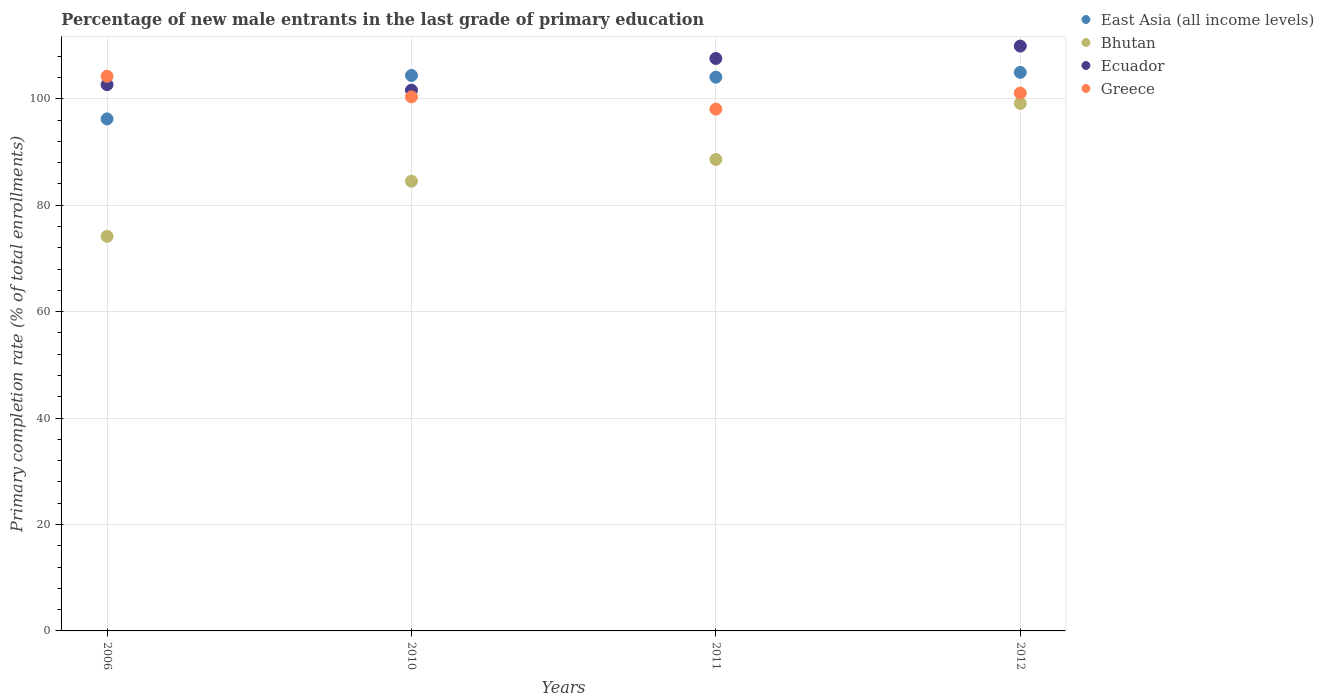How many different coloured dotlines are there?
Your response must be concise. 4. Is the number of dotlines equal to the number of legend labels?
Your answer should be compact. Yes. What is the percentage of new male entrants in Bhutan in 2011?
Your answer should be compact. 88.61. Across all years, what is the maximum percentage of new male entrants in Greece?
Your answer should be compact. 104.24. Across all years, what is the minimum percentage of new male entrants in Bhutan?
Your answer should be compact. 74.16. In which year was the percentage of new male entrants in Ecuador minimum?
Your answer should be compact. 2010. What is the total percentage of new male entrants in Bhutan in the graph?
Ensure brevity in your answer.  346.42. What is the difference between the percentage of new male entrants in Bhutan in 2010 and that in 2011?
Your response must be concise. -4.09. What is the difference between the percentage of new male entrants in Greece in 2011 and the percentage of new male entrants in East Asia (all income levels) in 2012?
Keep it short and to the point. -6.91. What is the average percentage of new male entrants in East Asia (all income levels) per year?
Ensure brevity in your answer.  102.41. In the year 2012, what is the difference between the percentage of new male entrants in Bhutan and percentage of new male entrants in East Asia (all income levels)?
Provide a short and direct response. -5.83. What is the ratio of the percentage of new male entrants in Greece in 2006 to that in 2012?
Ensure brevity in your answer.  1.03. Is the percentage of new male entrants in Greece in 2006 less than that in 2012?
Offer a very short reply. No. Is the difference between the percentage of new male entrants in Bhutan in 2006 and 2011 greater than the difference between the percentage of new male entrants in East Asia (all income levels) in 2006 and 2011?
Offer a terse response. No. What is the difference between the highest and the second highest percentage of new male entrants in East Asia (all income levels)?
Your answer should be very brief. 0.58. What is the difference between the highest and the lowest percentage of new male entrants in Bhutan?
Make the answer very short. 24.98. Is the sum of the percentage of new male entrants in East Asia (all income levels) in 2010 and 2011 greater than the maximum percentage of new male entrants in Bhutan across all years?
Provide a succinct answer. Yes. Is it the case that in every year, the sum of the percentage of new male entrants in Greece and percentage of new male entrants in East Asia (all income levels)  is greater than the sum of percentage of new male entrants in Bhutan and percentage of new male entrants in Ecuador?
Your answer should be very brief. Yes. Is it the case that in every year, the sum of the percentage of new male entrants in Ecuador and percentage of new male entrants in Greece  is greater than the percentage of new male entrants in Bhutan?
Your response must be concise. Yes. Does the percentage of new male entrants in Bhutan monotonically increase over the years?
Provide a short and direct response. Yes. How many years are there in the graph?
Your answer should be compact. 4. Are the values on the major ticks of Y-axis written in scientific E-notation?
Your answer should be very brief. No. What is the title of the graph?
Provide a short and direct response. Percentage of new male entrants in the last grade of primary education. Does "Niger" appear as one of the legend labels in the graph?
Your answer should be compact. No. What is the label or title of the Y-axis?
Give a very brief answer. Primary completion rate (% of total enrollments). What is the Primary completion rate (% of total enrollments) of East Asia (all income levels) in 2006?
Ensure brevity in your answer.  96.22. What is the Primary completion rate (% of total enrollments) in Bhutan in 2006?
Your answer should be very brief. 74.16. What is the Primary completion rate (% of total enrollments) in Ecuador in 2006?
Provide a succinct answer. 102.67. What is the Primary completion rate (% of total enrollments) in Greece in 2006?
Provide a short and direct response. 104.24. What is the Primary completion rate (% of total enrollments) of East Asia (all income levels) in 2010?
Give a very brief answer. 104.39. What is the Primary completion rate (% of total enrollments) of Bhutan in 2010?
Your answer should be compact. 84.52. What is the Primary completion rate (% of total enrollments) in Ecuador in 2010?
Give a very brief answer. 101.63. What is the Primary completion rate (% of total enrollments) of Greece in 2010?
Ensure brevity in your answer.  100.36. What is the Primary completion rate (% of total enrollments) in East Asia (all income levels) in 2011?
Make the answer very short. 104.07. What is the Primary completion rate (% of total enrollments) in Bhutan in 2011?
Offer a terse response. 88.61. What is the Primary completion rate (% of total enrollments) of Ecuador in 2011?
Provide a short and direct response. 107.58. What is the Primary completion rate (% of total enrollments) of Greece in 2011?
Offer a terse response. 98.06. What is the Primary completion rate (% of total enrollments) of East Asia (all income levels) in 2012?
Make the answer very short. 104.97. What is the Primary completion rate (% of total enrollments) of Bhutan in 2012?
Give a very brief answer. 99.14. What is the Primary completion rate (% of total enrollments) in Ecuador in 2012?
Your answer should be compact. 109.91. What is the Primary completion rate (% of total enrollments) of Greece in 2012?
Provide a succinct answer. 101.08. Across all years, what is the maximum Primary completion rate (% of total enrollments) in East Asia (all income levels)?
Your answer should be compact. 104.97. Across all years, what is the maximum Primary completion rate (% of total enrollments) of Bhutan?
Give a very brief answer. 99.14. Across all years, what is the maximum Primary completion rate (% of total enrollments) in Ecuador?
Offer a terse response. 109.91. Across all years, what is the maximum Primary completion rate (% of total enrollments) of Greece?
Your answer should be compact. 104.24. Across all years, what is the minimum Primary completion rate (% of total enrollments) in East Asia (all income levels)?
Your answer should be very brief. 96.22. Across all years, what is the minimum Primary completion rate (% of total enrollments) of Bhutan?
Offer a terse response. 74.16. Across all years, what is the minimum Primary completion rate (% of total enrollments) of Ecuador?
Keep it short and to the point. 101.63. Across all years, what is the minimum Primary completion rate (% of total enrollments) in Greece?
Your response must be concise. 98.06. What is the total Primary completion rate (% of total enrollments) of East Asia (all income levels) in the graph?
Your answer should be compact. 409.65. What is the total Primary completion rate (% of total enrollments) of Bhutan in the graph?
Keep it short and to the point. 346.42. What is the total Primary completion rate (% of total enrollments) of Ecuador in the graph?
Your answer should be compact. 421.79. What is the total Primary completion rate (% of total enrollments) in Greece in the graph?
Make the answer very short. 403.74. What is the difference between the Primary completion rate (% of total enrollments) in East Asia (all income levels) in 2006 and that in 2010?
Give a very brief answer. -8.17. What is the difference between the Primary completion rate (% of total enrollments) in Bhutan in 2006 and that in 2010?
Your answer should be compact. -10.36. What is the difference between the Primary completion rate (% of total enrollments) of Ecuador in 2006 and that in 2010?
Your answer should be compact. 1.04. What is the difference between the Primary completion rate (% of total enrollments) of Greece in 2006 and that in 2010?
Offer a terse response. 3.87. What is the difference between the Primary completion rate (% of total enrollments) of East Asia (all income levels) in 2006 and that in 2011?
Provide a short and direct response. -7.85. What is the difference between the Primary completion rate (% of total enrollments) in Bhutan in 2006 and that in 2011?
Provide a succinct answer. -14.45. What is the difference between the Primary completion rate (% of total enrollments) of Ecuador in 2006 and that in 2011?
Offer a terse response. -4.92. What is the difference between the Primary completion rate (% of total enrollments) in Greece in 2006 and that in 2011?
Provide a succinct answer. 6.18. What is the difference between the Primary completion rate (% of total enrollments) of East Asia (all income levels) in 2006 and that in 2012?
Provide a short and direct response. -8.75. What is the difference between the Primary completion rate (% of total enrollments) of Bhutan in 2006 and that in 2012?
Your response must be concise. -24.98. What is the difference between the Primary completion rate (% of total enrollments) of Ecuador in 2006 and that in 2012?
Offer a very short reply. -7.24. What is the difference between the Primary completion rate (% of total enrollments) in Greece in 2006 and that in 2012?
Make the answer very short. 3.16. What is the difference between the Primary completion rate (% of total enrollments) in East Asia (all income levels) in 2010 and that in 2011?
Your answer should be very brief. 0.32. What is the difference between the Primary completion rate (% of total enrollments) of Bhutan in 2010 and that in 2011?
Offer a terse response. -4.09. What is the difference between the Primary completion rate (% of total enrollments) of Ecuador in 2010 and that in 2011?
Ensure brevity in your answer.  -5.96. What is the difference between the Primary completion rate (% of total enrollments) in Greece in 2010 and that in 2011?
Offer a very short reply. 2.3. What is the difference between the Primary completion rate (% of total enrollments) of East Asia (all income levels) in 2010 and that in 2012?
Keep it short and to the point. -0.58. What is the difference between the Primary completion rate (% of total enrollments) in Bhutan in 2010 and that in 2012?
Keep it short and to the point. -14.62. What is the difference between the Primary completion rate (% of total enrollments) of Ecuador in 2010 and that in 2012?
Provide a succinct answer. -8.28. What is the difference between the Primary completion rate (% of total enrollments) of Greece in 2010 and that in 2012?
Your response must be concise. -0.72. What is the difference between the Primary completion rate (% of total enrollments) in East Asia (all income levels) in 2011 and that in 2012?
Offer a terse response. -0.9. What is the difference between the Primary completion rate (% of total enrollments) in Bhutan in 2011 and that in 2012?
Provide a succinct answer. -10.53. What is the difference between the Primary completion rate (% of total enrollments) of Ecuador in 2011 and that in 2012?
Make the answer very short. -2.33. What is the difference between the Primary completion rate (% of total enrollments) of Greece in 2011 and that in 2012?
Your answer should be compact. -3.02. What is the difference between the Primary completion rate (% of total enrollments) of East Asia (all income levels) in 2006 and the Primary completion rate (% of total enrollments) of Bhutan in 2010?
Provide a short and direct response. 11.7. What is the difference between the Primary completion rate (% of total enrollments) in East Asia (all income levels) in 2006 and the Primary completion rate (% of total enrollments) in Ecuador in 2010?
Your answer should be very brief. -5.4. What is the difference between the Primary completion rate (% of total enrollments) of East Asia (all income levels) in 2006 and the Primary completion rate (% of total enrollments) of Greece in 2010?
Ensure brevity in your answer.  -4.14. What is the difference between the Primary completion rate (% of total enrollments) in Bhutan in 2006 and the Primary completion rate (% of total enrollments) in Ecuador in 2010?
Your answer should be compact. -27.47. What is the difference between the Primary completion rate (% of total enrollments) of Bhutan in 2006 and the Primary completion rate (% of total enrollments) of Greece in 2010?
Your answer should be compact. -26.2. What is the difference between the Primary completion rate (% of total enrollments) in Ecuador in 2006 and the Primary completion rate (% of total enrollments) in Greece in 2010?
Keep it short and to the point. 2.31. What is the difference between the Primary completion rate (% of total enrollments) of East Asia (all income levels) in 2006 and the Primary completion rate (% of total enrollments) of Bhutan in 2011?
Your answer should be compact. 7.62. What is the difference between the Primary completion rate (% of total enrollments) in East Asia (all income levels) in 2006 and the Primary completion rate (% of total enrollments) in Ecuador in 2011?
Offer a very short reply. -11.36. What is the difference between the Primary completion rate (% of total enrollments) in East Asia (all income levels) in 2006 and the Primary completion rate (% of total enrollments) in Greece in 2011?
Offer a terse response. -1.84. What is the difference between the Primary completion rate (% of total enrollments) of Bhutan in 2006 and the Primary completion rate (% of total enrollments) of Ecuador in 2011?
Keep it short and to the point. -33.43. What is the difference between the Primary completion rate (% of total enrollments) of Bhutan in 2006 and the Primary completion rate (% of total enrollments) of Greece in 2011?
Provide a short and direct response. -23.9. What is the difference between the Primary completion rate (% of total enrollments) in Ecuador in 2006 and the Primary completion rate (% of total enrollments) in Greece in 2011?
Offer a terse response. 4.61. What is the difference between the Primary completion rate (% of total enrollments) of East Asia (all income levels) in 2006 and the Primary completion rate (% of total enrollments) of Bhutan in 2012?
Offer a terse response. -2.91. What is the difference between the Primary completion rate (% of total enrollments) in East Asia (all income levels) in 2006 and the Primary completion rate (% of total enrollments) in Ecuador in 2012?
Your answer should be very brief. -13.69. What is the difference between the Primary completion rate (% of total enrollments) of East Asia (all income levels) in 2006 and the Primary completion rate (% of total enrollments) of Greece in 2012?
Keep it short and to the point. -4.86. What is the difference between the Primary completion rate (% of total enrollments) in Bhutan in 2006 and the Primary completion rate (% of total enrollments) in Ecuador in 2012?
Offer a terse response. -35.75. What is the difference between the Primary completion rate (% of total enrollments) in Bhutan in 2006 and the Primary completion rate (% of total enrollments) in Greece in 2012?
Keep it short and to the point. -26.92. What is the difference between the Primary completion rate (% of total enrollments) in Ecuador in 2006 and the Primary completion rate (% of total enrollments) in Greece in 2012?
Offer a very short reply. 1.59. What is the difference between the Primary completion rate (% of total enrollments) of East Asia (all income levels) in 2010 and the Primary completion rate (% of total enrollments) of Bhutan in 2011?
Give a very brief answer. 15.79. What is the difference between the Primary completion rate (% of total enrollments) in East Asia (all income levels) in 2010 and the Primary completion rate (% of total enrollments) in Ecuador in 2011?
Your answer should be compact. -3.19. What is the difference between the Primary completion rate (% of total enrollments) of East Asia (all income levels) in 2010 and the Primary completion rate (% of total enrollments) of Greece in 2011?
Your response must be concise. 6.33. What is the difference between the Primary completion rate (% of total enrollments) in Bhutan in 2010 and the Primary completion rate (% of total enrollments) in Ecuador in 2011?
Provide a short and direct response. -23.06. What is the difference between the Primary completion rate (% of total enrollments) in Bhutan in 2010 and the Primary completion rate (% of total enrollments) in Greece in 2011?
Your response must be concise. -13.54. What is the difference between the Primary completion rate (% of total enrollments) in Ecuador in 2010 and the Primary completion rate (% of total enrollments) in Greece in 2011?
Ensure brevity in your answer.  3.57. What is the difference between the Primary completion rate (% of total enrollments) of East Asia (all income levels) in 2010 and the Primary completion rate (% of total enrollments) of Bhutan in 2012?
Offer a terse response. 5.26. What is the difference between the Primary completion rate (% of total enrollments) of East Asia (all income levels) in 2010 and the Primary completion rate (% of total enrollments) of Ecuador in 2012?
Provide a short and direct response. -5.52. What is the difference between the Primary completion rate (% of total enrollments) in East Asia (all income levels) in 2010 and the Primary completion rate (% of total enrollments) in Greece in 2012?
Give a very brief answer. 3.31. What is the difference between the Primary completion rate (% of total enrollments) of Bhutan in 2010 and the Primary completion rate (% of total enrollments) of Ecuador in 2012?
Ensure brevity in your answer.  -25.39. What is the difference between the Primary completion rate (% of total enrollments) of Bhutan in 2010 and the Primary completion rate (% of total enrollments) of Greece in 2012?
Your answer should be very brief. -16.56. What is the difference between the Primary completion rate (% of total enrollments) of Ecuador in 2010 and the Primary completion rate (% of total enrollments) of Greece in 2012?
Offer a very short reply. 0.55. What is the difference between the Primary completion rate (% of total enrollments) in East Asia (all income levels) in 2011 and the Primary completion rate (% of total enrollments) in Bhutan in 2012?
Provide a succinct answer. 4.93. What is the difference between the Primary completion rate (% of total enrollments) in East Asia (all income levels) in 2011 and the Primary completion rate (% of total enrollments) in Ecuador in 2012?
Your answer should be compact. -5.84. What is the difference between the Primary completion rate (% of total enrollments) in East Asia (all income levels) in 2011 and the Primary completion rate (% of total enrollments) in Greece in 2012?
Offer a terse response. 2.99. What is the difference between the Primary completion rate (% of total enrollments) in Bhutan in 2011 and the Primary completion rate (% of total enrollments) in Ecuador in 2012?
Your answer should be very brief. -21.3. What is the difference between the Primary completion rate (% of total enrollments) in Bhutan in 2011 and the Primary completion rate (% of total enrollments) in Greece in 2012?
Provide a short and direct response. -12.47. What is the difference between the Primary completion rate (% of total enrollments) of Ecuador in 2011 and the Primary completion rate (% of total enrollments) of Greece in 2012?
Your answer should be very brief. 6.5. What is the average Primary completion rate (% of total enrollments) of East Asia (all income levels) per year?
Ensure brevity in your answer.  102.41. What is the average Primary completion rate (% of total enrollments) of Bhutan per year?
Keep it short and to the point. 86.6. What is the average Primary completion rate (% of total enrollments) of Ecuador per year?
Your answer should be very brief. 105.45. What is the average Primary completion rate (% of total enrollments) in Greece per year?
Offer a very short reply. 100.93. In the year 2006, what is the difference between the Primary completion rate (% of total enrollments) in East Asia (all income levels) and Primary completion rate (% of total enrollments) in Bhutan?
Make the answer very short. 22.07. In the year 2006, what is the difference between the Primary completion rate (% of total enrollments) of East Asia (all income levels) and Primary completion rate (% of total enrollments) of Ecuador?
Offer a terse response. -6.45. In the year 2006, what is the difference between the Primary completion rate (% of total enrollments) in East Asia (all income levels) and Primary completion rate (% of total enrollments) in Greece?
Provide a short and direct response. -8.01. In the year 2006, what is the difference between the Primary completion rate (% of total enrollments) of Bhutan and Primary completion rate (% of total enrollments) of Ecuador?
Keep it short and to the point. -28.51. In the year 2006, what is the difference between the Primary completion rate (% of total enrollments) in Bhutan and Primary completion rate (% of total enrollments) in Greece?
Offer a terse response. -30.08. In the year 2006, what is the difference between the Primary completion rate (% of total enrollments) in Ecuador and Primary completion rate (% of total enrollments) in Greece?
Ensure brevity in your answer.  -1.57. In the year 2010, what is the difference between the Primary completion rate (% of total enrollments) in East Asia (all income levels) and Primary completion rate (% of total enrollments) in Bhutan?
Offer a very short reply. 19.87. In the year 2010, what is the difference between the Primary completion rate (% of total enrollments) in East Asia (all income levels) and Primary completion rate (% of total enrollments) in Ecuador?
Give a very brief answer. 2.76. In the year 2010, what is the difference between the Primary completion rate (% of total enrollments) of East Asia (all income levels) and Primary completion rate (% of total enrollments) of Greece?
Keep it short and to the point. 4.03. In the year 2010, what is the difference between the Primary completion rate (% of total enrollments) of Bhutan and Primary completion rate (% of total enrollments) of Ecuador?
Provide a short and direct response. -17.11. In the year 2010, what is the difference between the Primary completion rate (% of total enrollments) of Bhutan and Primary completion rate (% of total enrollments) of Greece?
Provide a short and direct response. -15.84. In the year 2010, what is the difference between the Primary completion rate (% of total enrollments) in Ecuador and Primary completion rate (% of total enrollments) in Greece?
Ensure brevity in your answer.  1.26. In the year 2011, what is the difference between the Primary completion rate (% of total enrollments) in East Asia (all income levels) and Primary completion rate (% of total enrollments) in Bhutan?
Your answer should be very brief. 15.46. In the year 2011, what is the difference between the Primary completion rate (% of total enrollments) of East Asia (all income levels) and Primary completion rate (% of total enrollments) of Ecuador?
Your answer should be very brief. -3.51. In the year 2011, what is the difference between the Primary completion rate (% of total enrollments) in East Asia (all income levels) and Primary completion rate (% of total enrollments) in Greece?
Provide a succinct answer. 6.01. In the year 2011, what is the difference between the Primary completion rate (% of total enrollments) of Bhutan and Primary completion rate (% of total enrollments) of Ecuador?
Make the answer very short. -18.98. In the year 2011, what is the difference between the Primary completion rate (% of total enrollments) of Bhutan and Primary completion rate (% of total enrollments) of Greece?
Keep it short and to the point. -9.45. In the year 2011, what is the difference between the Primary completion rate (% of total enrollments) of Ecuador and Primary completion rate (% of total enrollments) of Greece?
Keep it short and to the point. 9.52. In the year 2012, what is the difference between the Primary completion rate (% of total enrollments) of East Asia (all income levels) and Primary completion rate (% of total enrollments) of Bhutan?
Ensure brevity in your answer.  5.83. In the year 2012, what is the difference between the Primary completion rate (% of total enrollments) of East Asia (all income levels) and Primary completion rate (% of total enrollments) of Ecuador?
Provide a short and direct response. -4.94. In the year 2012, what is the difference between the Primary completion rate (% of total enrollments) in East Asia (all income levels) and Primary completion rate (% of total enrollments) in Greece?
Offer a terse response. 3.89. In the year 2012, what is the difference between the Primary completion rate (% of total enrollments) in Bhutan and Primary completion rate (% of total enrollments) in Ecuador?
Ensure brevity in your answer.  -10.77. In the year 2012, what is the difference between the Primary completion rate (% of total enrollments) of Bhutan and Primary completion rate (% of total enrollments) of Greece?
Your answer should be compact. -1.94. In the year 2012, what is the difference between the Primary completion rate (% of total enrollments) of Ecuador and Primary completion rate (% of total enrollments) of Greece?
Your answer should be compact. 8.83. What is the ratio of the Primary completion rate (% of total enrollments) in East Asia (all income levels) in 2006 to that in 2010?
Ensure brevity in your answer.  0.92. What is the ratio of the Primary completion rate (% of total enrollments) of Bhutan in 2006 to that in 2010?
Offer a terse response. 0.88. What is the ratio of the Primary completion rate (% of total enrollments) of Ecuador in 2006 to that in 2010?
Your response must be concise. 1.01. What is the ratio of the Primary completion rate (% of total enrollments) of Greece in 2006 to that in 2010?
Give a very brief answer. 1.04. What is the ratio of the Primary completion rate (% of total enrollments) of East Asia (all income levels) in 2006 to that in 2011?
Ensure brevity in your answer.  0.92. What is the ratio of the Primary completion rate (% of total enrollments) in Bhutan in 2006 to that in 2011?
Your response must be concise. 0.84. What is the ratio of the Primary completion rate (% of total enrollments) in Ecuador in 2006 to that in 2011?
Your response must be concise. 0.95. What is the ratio of the Primary completion rate (% of total enrollments) in Greece in 2006 to that in 2011?
Offer a terse response. 1.06. What is the ratio of the Primary completion rate (% of total enrollments) of Bhutan in 2006 to that in 2012?
Offer a terse response. 0.75. What is the ratio of the Primary completion rate (% of total enrollments) in Ecuador in 2006 to that in 2012?
Your answer should be very brief. 0.93. What is the ratio of the Primary completion rate (% of total enrollments) of Greece in 2006 to that in 2012?
Offer a terse response. 1.03. What is the ratio of the Primary completion rate (% of total enrollments) in Bhutan in 2010 to that in 2011?
Give a very brief answer. 0.95. What is the ratio of the Primary completion rate (% of total enrollments) in Ecuador in 2010 to that in 2011?
Provide a short and direct response. 0.94. What is the ratio of the Primary completion rate (% of total enrollments) of Greece in 2010 to that in 2011?
Provide a short and direct response. 1.02. What is the ratio of the Primary completion rate (% of total enrollments) in East Asia (all income levels) in 2010 to that in 2012?
Make the answer very short. 0.99. What is the ratio of the Primary completion rate (% of total enrollments) of Bhutan in 2010 to that in 2012?
Your answer should be very brief. 0.85. What is the ratio of the Primary completion rate (% of total enrollments) in Ecuador in 2010 to that in 2012?
Give a very brief answer. 0.92. What is the ratio of the Primary completion rate (% of total enrollments) in Greece in 2010 to that in 2012?
Offer a terse response. 0.99. What is the ratio of the Primary completion rate (% of total enrollments) of Bhutan in 2011 to that in 2012?
Offer a very short reply. 0.89. What is the ratio of the Primary completion rate (% of total enrollments) in Ecuador in 2011 to that in 2012?
Make the answer very short. 0.98. What is the ratio of the Primary completion rate (% of total enrollments) in Greece in 2011 to that in 2012?
Offer a terse response. 0.97. What is the difference between the highest and the second highest Primary completion rate (% of total enrollments) in East Asia (all income levels)?
Ensure brevity in your answer.  0.58. What is the difference between the highest and the second highest Primary completion rate (% of total enrollments) of Bhutan?
Provide a succinct answer. 10.53. What is the difference between the highest and the second highest Primary completion rate (% of total enrollments) of Ecuador?
Keep it short and to the point. 2.33. What is the difference between the highest and the second highest Primary completion rate (% of total enrollments) in Greece?
Provide a short and direct response. 3.16. What is the difference between the highest and the lowest Primary completion rate (% of total enrollments) of East Asia (all income levels)?
Keep it short and to the point. 8.75. What is the difference between the highest and the lowest Primary completion rate (% of total enrollments) in Bhutan?
Offer a terse response. 24.98. What is the difference between the highest and the lowest Primary completion rate (% of total enrollments) in Ecuador?
Keep it short and to the point. 8.28. What is the difference between the highest and the lowest Primary completion rate (% of total enrollments) of Greece?
Your response must be concise. 6.18. 